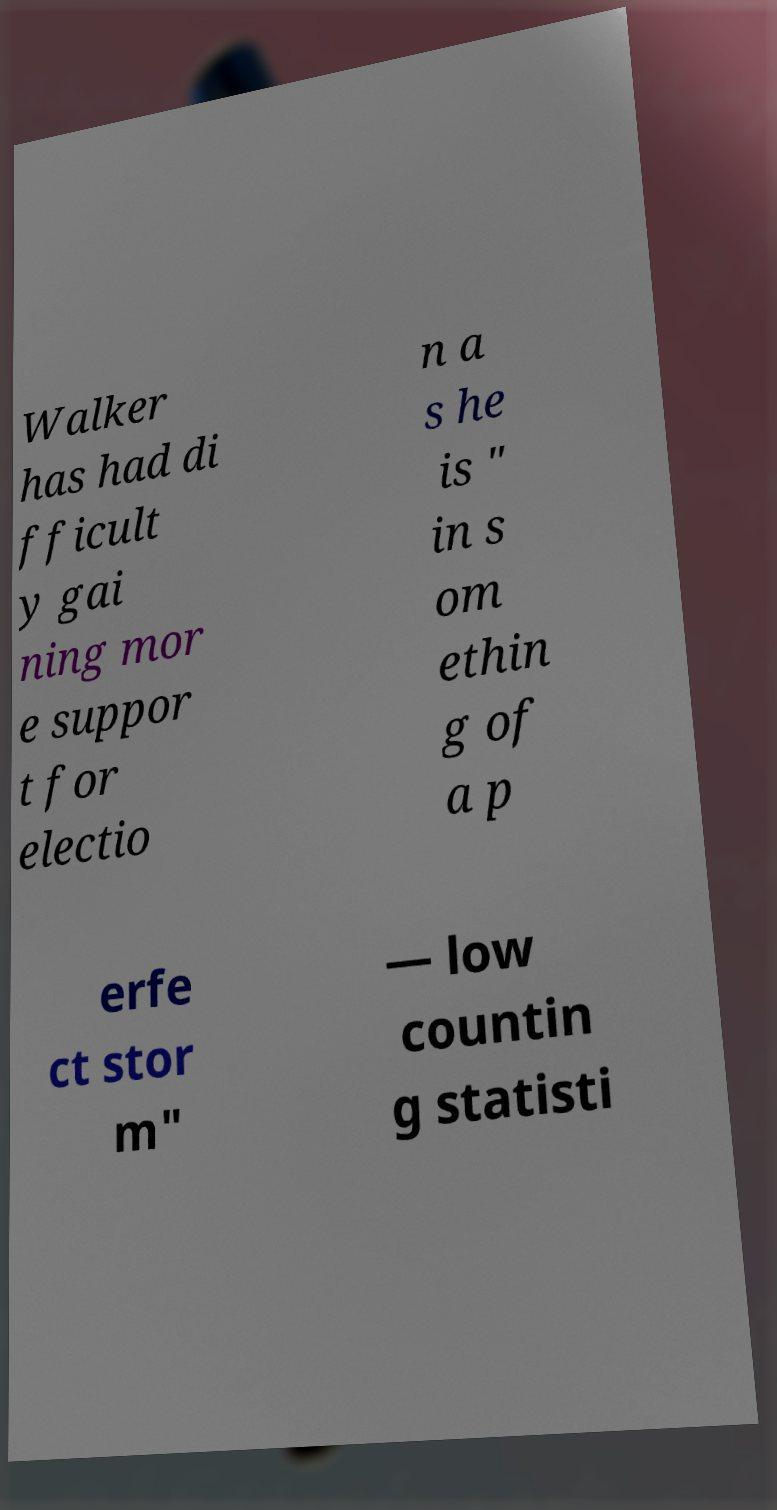Please identify and transcribe the text found in this image. Walker has had di fficult y gai ning mor e suppor t for electio n a s he is " in s om ethin g of a p erfe ct stor m" — low countin g statisti 